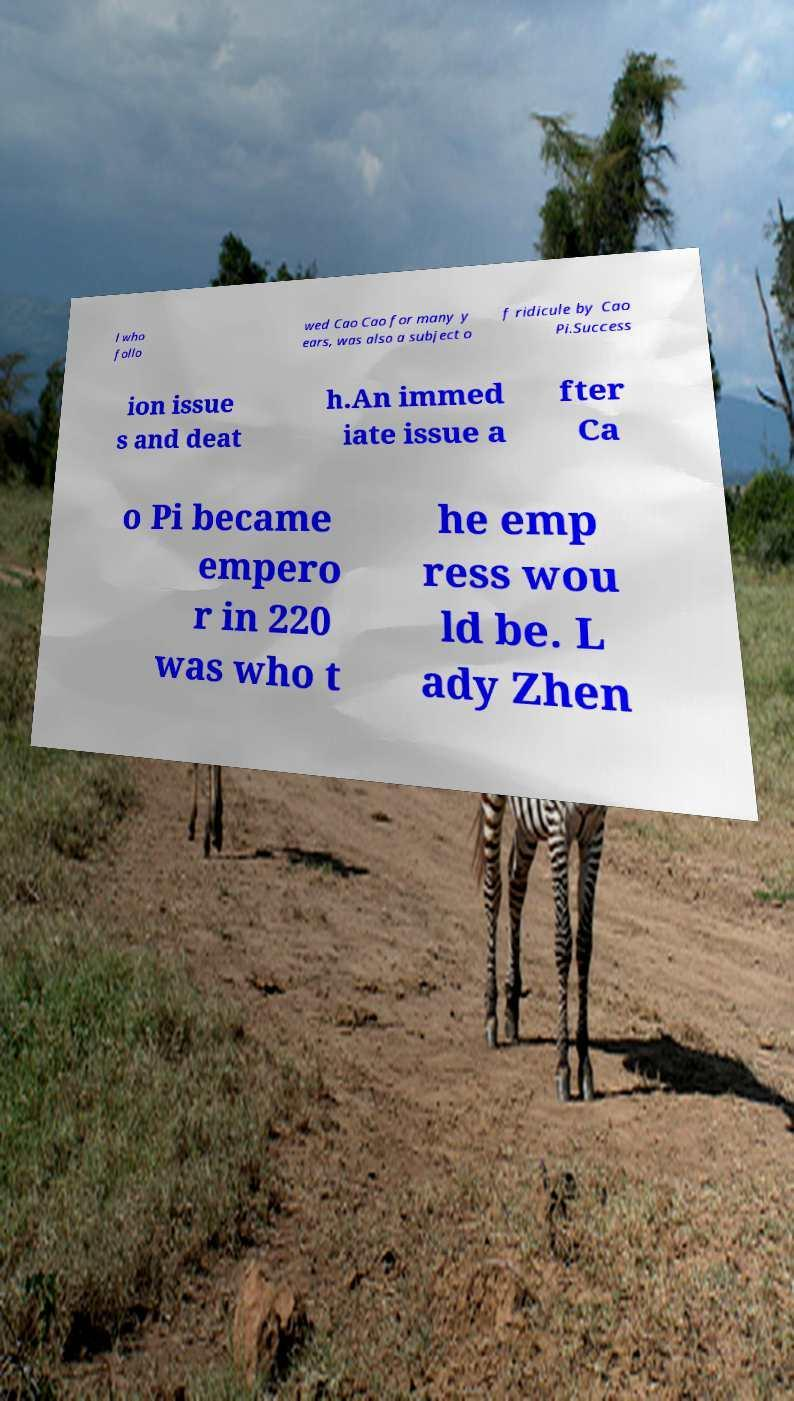For documentation purposes, I need the text within this image transcribed. Could you provide that? l who follo wed Cao Cao for many y ears, was also a subject o f ridicule by Cao Pi.Success ion issue s and deat h.An immed iate issue a fter Ca o Pi became empero r in 220 was who t he emp ress wou ld be. L ady Zhen 